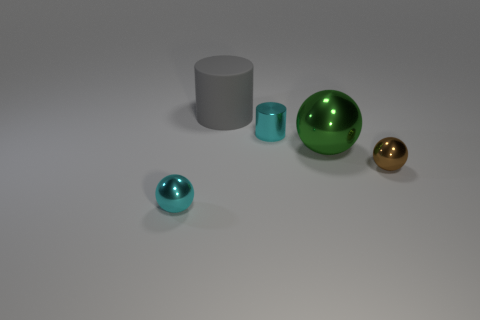Subtract all purple cylinders. Subtract all green spheres. How many cylinders are left? 2 Add 2 big red rubber blocks. How many objects exist? 7 Subtract all balls. How many objects are left? 2 Subtract all purple rubber objects. Subtract all big metallic things. How many objects are left? 4 Add 5 large rubber things. How many large rubber things are left? 6 Add 4 small yellow matte cylinders. How many small yellow matte cylinders exist? 4 Subtract 1 gray cylinders. How many objects are left? 4 